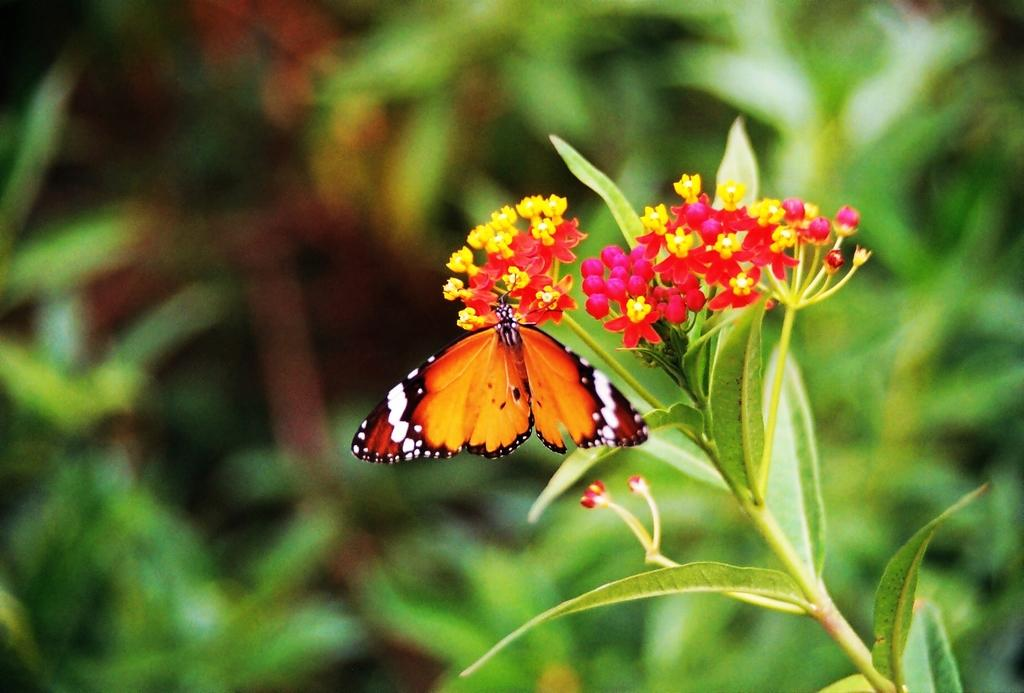What type of plant is on the right side of the image? There is a plant with flowers on the right side of the image. What is on the flowers in the image? There is a butterfly on the flowers. How would you describe the background of the image? The background of the image is blurred. What else can be seen in the background of the image? Plants are visible in the background of the image. What type of pain is the butterfly experiencing in the image? There is no indication of pain in the image; the butterfly is simply resting on the flowers. 